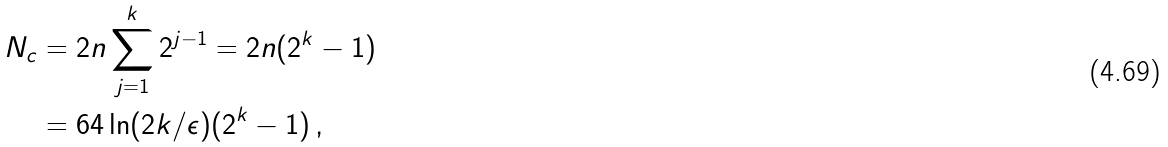<formula> <loc_0><loc_0><loc_500><loc_500>N _ { c } & = 2 n \sum _ { j = 1 } ^ { k } 2 ^ { j - 1 } = 2 n ( 2 ^ { k } - 1 ) \\ & = 6 4 \ln ( 2 k / \epsilon ) ( 2 ^ { k } - 1 ) \, ,</formula> 